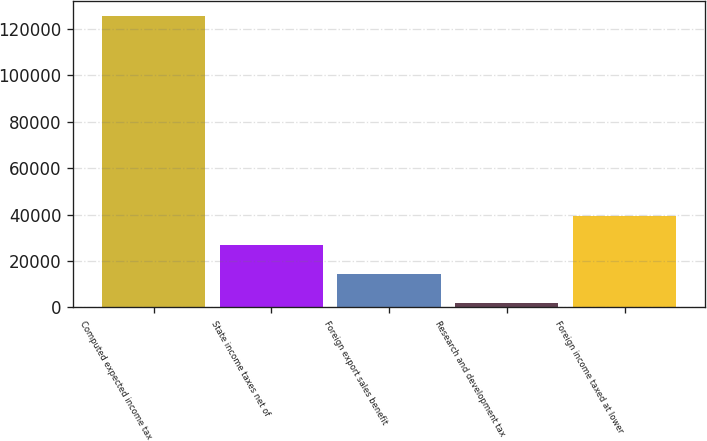<chart> <loc_0><loc_0><loc_500><loc_500><bar_chart><fcel>Computed expected income tax<fcel>State income taxes net of<fcel>Foreign export sales benefit<fcel>Research and development tax<fcel>Foreign income taxed at lower<nl><fcel>125715<fcel>26819<fcel>14457<fcel>2095<fcel>39181<nl></chart> 